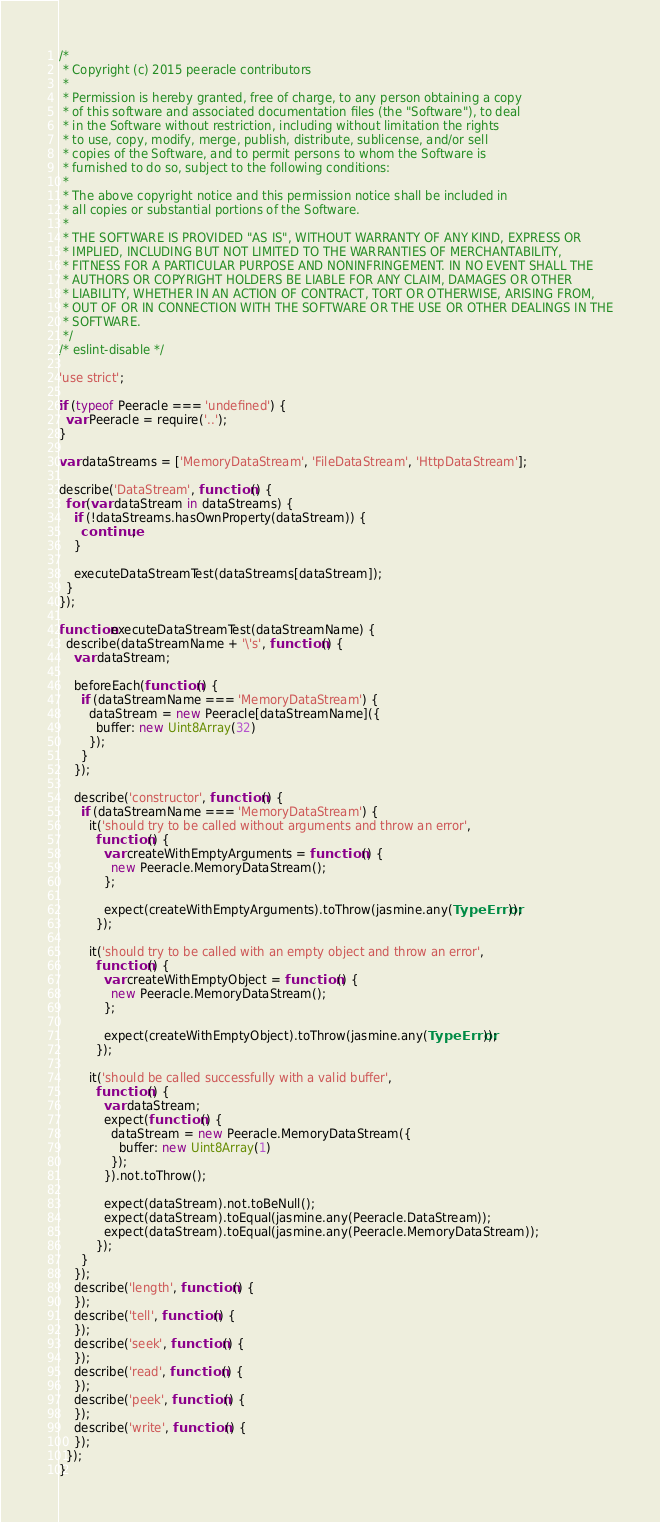<code> <loc_0><loc_0><loc_500><loc_500><_JavaScript_>/*
 * Copyright (c) 2015 peeracle contributors
 *
 * Permission is hereby granted, free of charge, to any person obtaining a copy
 * of this software and associated documentation files (the "Software"), to deal
 * in the Software without restriction, including without limitation the rights
 * to use, copy, modify, merge, publish, distribute, sublicense, and/or sell
 * copies of the Software, and to permit persons to whom the Software is
 * furnished to do so, subject to the following conditions:
 *
 * The above copyright notice and this permission notice shall be included in
 * all copies or substantial portions of the Software.
 *
 * THE SOFTWARE IS PROVIDED "AS IS", WITHOUT WARRANTY OF ANY KIND, EXPRESS OR
 * IMPLIED, INCLUDING BUT NOT LIMITED TO THE WARRANTIES OF MERCHANTABILITY,
 * FITNESS FOR A PARTICULAR PURPOSE AND NONINFRINGEMENT. IN NO EVENT SHALL THE
 * AUTHORS OR COPYRIGHT HOLDERS BE LIABLE FOR ANY CLAIM, DAMAGES OR OTHER
 * LIABILITY, WHETHER IN AN ACTION OF CONTRACT, TORT OR OTHERWISE, ARISING FROM,
 * OUT OF OR IN CONNECTION WITH THE SOFTWARE OR THE USE OR OTHER DEALINGS IN THE
 * SOFTWARE.
 */
/* eslint-disable */

'use strict';

if (typeof Peeracle === 'undefined') {
  var Peeracle = require('..');
}

var dataStreams = ['MemoryDataStream', 'FileDataStream', 'HttpDataStream'];

describe('DataStream', function () {
  for (var dataStream in dataStreams) {
    if (!dataStreams.hasOwnProperty(dataStream)) {
      continue;
    }

    executeDataStreamTest(dataStreams[dataStream]);
  }
});

function executeDataStreamTest(dataStreamName) {
  describe(dataStreamName + '\'s', function () {
    var dataStream;

    beforeEach(function () {
      if (dataStreamName === 'MemoryDataStream') {
        dataStream = new Peeracle[dataStreamName]({
          buffer: new Uint8Array(32)
        });
      }
    });

    describe('constructor', function () {
      if (dataStreamName === 'MemoryDataStream') {
        it('should try to be called without arguments and throw an error',
          function () {
            var createWithEmptyArguments = function () {
              new Peeracle.MemoryDataStream();
            };

            expect(createWithEmptyArguments).toThrow(jasmine.any(TypeError));
          });

        it('should try to be called with an empty object and throw an error',
          function () {
            var createWithEmptyObject = function () {
              new Peeracle.MemoryDataStream();
            };

            expect(createWithEmptyObject).toThrow(jasmine.any(TypeError));
          });

        it('should be called successfully with a valid buffer',
          function () {
            var dataStream;
            expect(function () {
              dataStream = new Peeracle.MemoryDataStream({
                buffer: new Uint8Array(1)
              });
            }).not.toThrow();

            expect(dataStream).not.toBeNull();
            expect(dataStream).toEqual(jasmine.any(Peeracle.DataStream));
            expect(dataStream).toEqual(jasmine.any(Peeracle.MemoryDataStream));
          });
      }
    });
    describe('length', function () {
    });
    describe('tell', function () {
    });
    describe('seek', function () {
    });
    describe('read', function () {
    });
    describe('peek', function () {
    });
    describe('write', function () {
    });
  });
}
</code> 